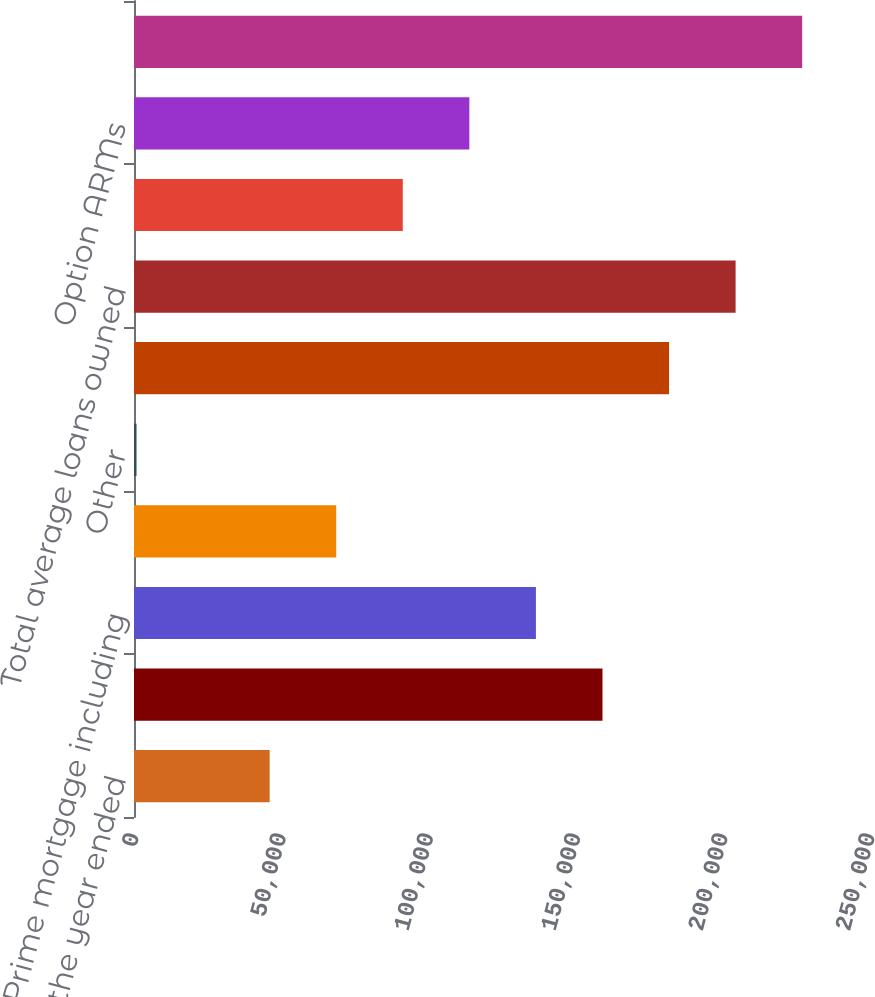<chart> <loc_0><loc_0><loc_500><loc_500><bar_chart><fcel>As of or for the year ended<fcel>Home equity<fcel>Prime mortgage including<fcel>Subprime mortgage<fcel>Other<fcel>Total period-end loans owned<fcel>Total average loans owned<fcel>Prime mortgage<fcel>Option ARMs<fcel>Average assets<nl><fcel>46077.8<fcel>159130<fcel>136519<fcel>68688.2<fcel>857<fcel>181740<fcel>204351<fcel>91298.6<fcel>113909<fcel>226961<nl></chart> 